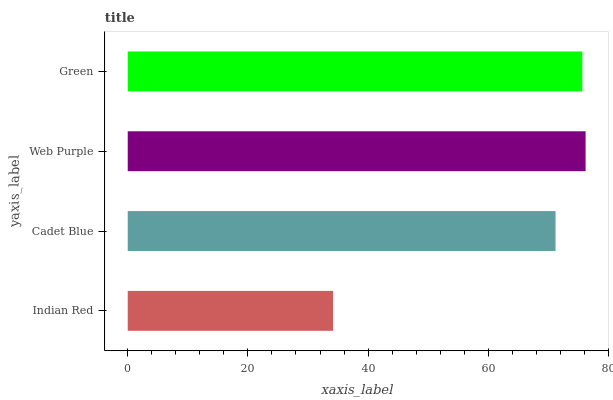Is Indian Red the minimum?
Answer yes or no. Yes. Is Web Purple the maximum?
Answer yes or no. Yes. Is Cadet Blue the minimum?
Answer yes or no. No. Is Cadet Blue the maximum?
Answer yes or no. No. Is Cadet Blue greater than Indian Red?
Answer yes or no. Yes. Is Indian Red less than Cadet Blue?
Answer yes or no. Yes. Is Indian Red greater than Cadet Blue?
Answer yes or no. No. Is Cadet Blue less than Indian Red?
Answer yes or no. No. Is Green the high median?
Answer yes or no. Yes. Is Cadet Blue the low median?
Answer yes or no. Yes. Is Indian Red the high median?
Answer yes or no. No. Is Green the low median?
Answer yes or no. No. 